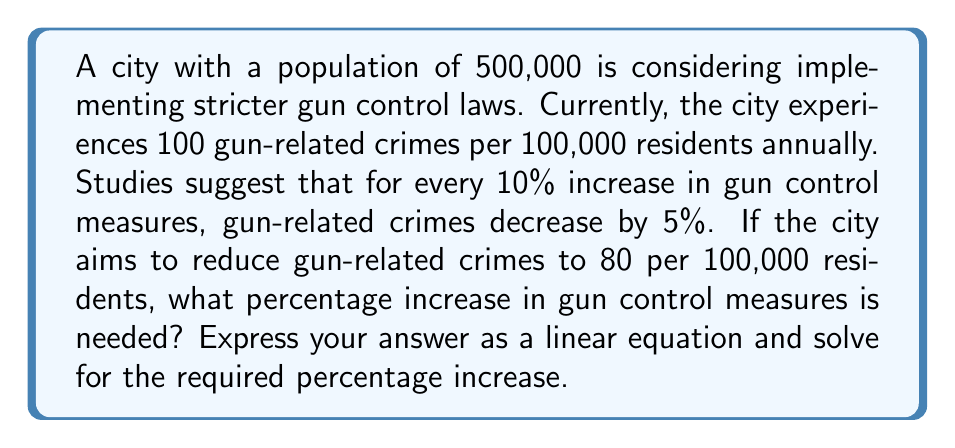Teach me how to tackle this problem. Let's approach this step-by-step:

1) First, let's define our variables:
   $x$ = percentage increase in gun control measures
   $y$ = number of gun-related crimes per 100,000 residents

2) We know that for every 10% increase in gun control, crimes decrease by 5%.
   This can be expressed as: For every $x$ increase, $y$ decreases by $\frac{x}{2}$.

3) We can now form a linear equation:
   $y = 100 - \frac{x}{2}$

4) We want $y$ to equal 80, so we can substitute this into our equation:
   $80 = 100 - \frac{x}{2}$

5) Now, let's solve for $x$:
   $80 - 100 = -\frac{x}{2}$
   $-20 = -\frac{x}{2}$

6) Multiply both sides by -2:
   $40 = x$

7) Therefore, a 40% increase in gun control measures is needed to reduce gun-related crimes to 80 per 100,000 residents.

8) We can verify this:
   $100 - (40 \times 0.5) = 100 - 20 = 80$

This solution demonstrates how linear equations can model the impact of gun control policies on crime rates, providing a quantitative basis for policy decisions.
Answer: A 40% increase in gun control measures is needed. The linear equation is $y = 100 - \frac{x}{2}$, where $x$ is the percentage increase in gun control measures and $y$ is the number of gun-related crimes per 100,000 residents. 